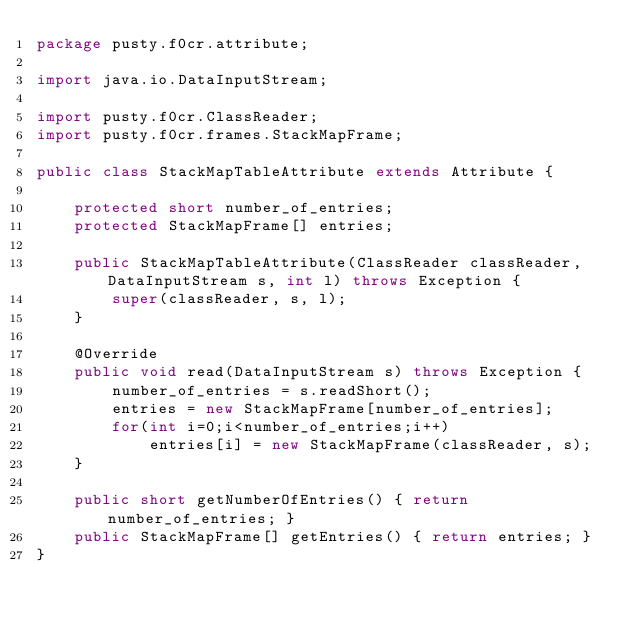<code> <loc_0><loc_0><loc_500><loc_500><_Java_>package pusty.f0cr.attribute;

import java.io.DataInputStream;

import pusty.f0cr.ClassReader;
import pusty.f0cr.frames.StackMapFrame;

public class StackMapTableAttribute extends Attribute {
	
	protected short number_of_entries;
	protected StackMapFrame[] entries;
	
	public StackMapTableAttribute(ClassReader classReader, DataInputStream s, int l) throws Exception {
		super(classReader, s, l);
	}

	@Override
	public void read(DataInputStream s) throws Exception {
		number_of_entries = s.readShort();
		entries = new StackMapFrame[number_of_entries];
		for(int i=0;i<number_of_entries;i++)
			entries[i] = new StackMapFrame(classReader, s);
	}
	
	public short getNumberOfEntries() { return number_of_entries; }
	public StackMapFrame[] getEntries() { return entries; }
}
</code> 